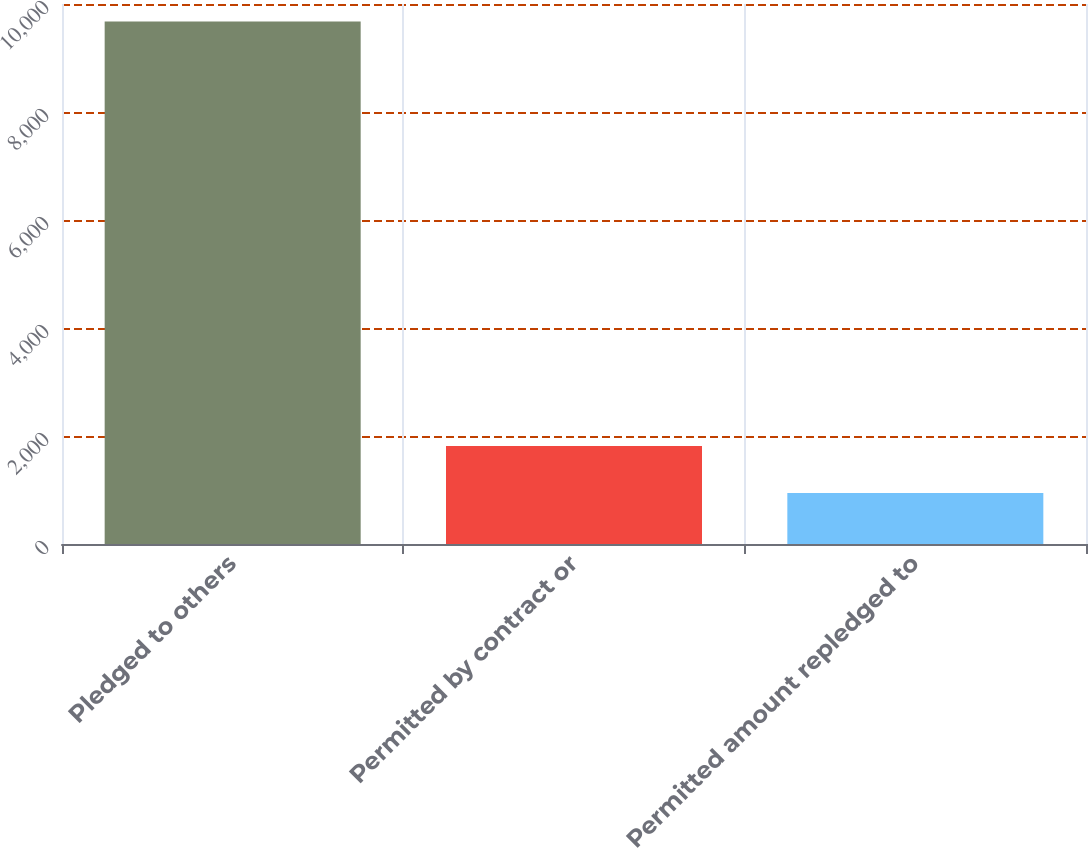Convert chart to OTSL. <chart><loc_0><loc_0><loc_500><loc_500><bar_chart><fcel>Pledged to others<fcel>Permitted by contract or<fcel>Permitted amount repledged to<nl><fcel>9674<fcel>1816.1<fcel>943<nl></chart> 